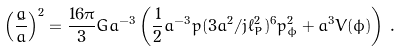<formula> <loc_0><loc_0><loc_500><loc_500>\left ( \frac { \dot { a } } { a } \right ) ^ { 2 } = \frac { 1 6 \pi } { 3 } G a ^ { - 3 } \left ( \frac { 1 } { 2 } a ^ { - 3 } p ( 3 a ^ { 2 } / j \ell _ { P } ^ { 2 } ) ^ { 6 } p _ { \phi } ^ { 2 } + a ^ { 3 } V ( \phi ) \right ) \, .</formula> 